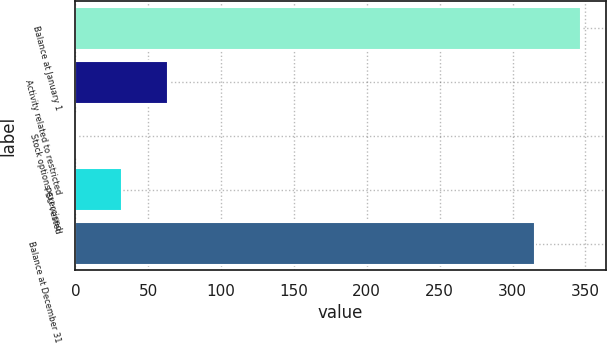<chart> <loc_0><loc_0><loc_500><loc_500><bar_chart><fcel>Balance at January 1<fcel>Activity related to restricted<fcel>Stock options exercised<fcel>PSU vested<fcel>Balance at December 31<nl><fcel>346.73<fcel>63.46<fcel>0.2<fcel>31.83<fcel>315.1<nl></chart> 